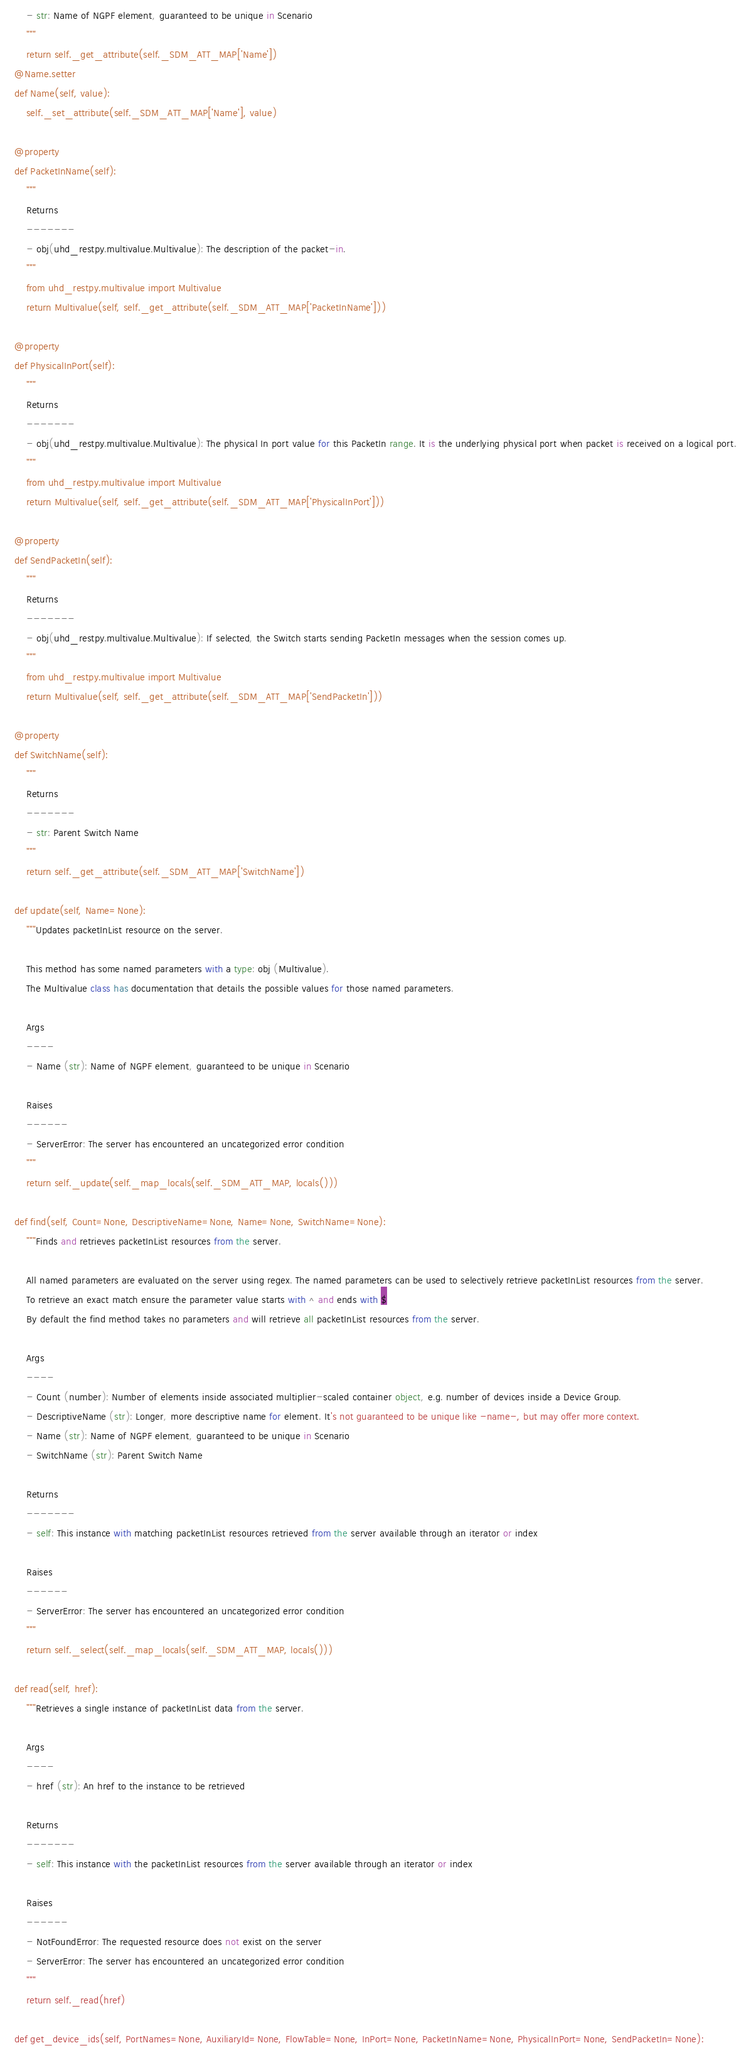<code> <loc_0><loc_0><loc_500><loc_500><_Python_>        - str: Name of NGPF element, guaranteed to be unique in Scenario
        """
        return self._get_attribute(self._SDM_ATT_MAP['Name'])
    @Name.setter
    def Name(self, value):
        self._set_attribute(self._SDM_ATT_MAP['Name'], value)

    @property
    def PacketInName(self):
        """
        Returns
        -------
        - obj(uhd_restpy.multivalue.Multivalue): The description of the packet-in.
        """
        from uhd_restpy.multivalue import Multivalue
        return Multivalue(self, self._get_attribute(self._SDM_ATT_MAP['PacketInName']))

    @property
    def PhysicalInPort(self):
        """
        Returns
        -------
        - obj(uhd_restpy.multivalue.Multivalue): The physical In port value for this PacketIn range. It is the underlying physical port when packet is received on a logical port.
        """
        from uhd_restpy.multivalue import Multivalue
        return Multivalue(self, self._get_attribute(self._SDM_ATT_MAP['PhysicalInPort']))

    @property
    def SendPacketIn(self):
        """
        Returns
        -------
        - obj(uhd_restpy.multivalue.Multivalue): If selected, the Switch starts sending PacketIn messages when the session comes up.
        """
        from uhd_restpy.multivalue import Multivalue
        return Multivalue(self, self._get_attribute(self._SDM_ATT_MAP['SendPacketIn']))

    @property
    def SwitchName(self):
        """
        Returns
        -------
        - str: Parent Switch Name
        """
        return self._get_attribute(self._SDM_ATT_MAP['SwitchName'])

    def update(self, Name=None):
        """Updates packetInList resource on the server.

        This method has some named parameters with a type: obj (Multivalue).
        The Multivalue class has documentation that details the possible values for those named parameters.

        Args
        ----
        - Name (str): Name of NGPF element, guaranteed to be unique in Scenario

        Raises
        ------
        - ServerError: The server has encountered an uncategorized error condition
        """
        return self._update(self._map_locals(self._SDM_ATT_MAP, locals()))

    def find(self, Count=None, DescriptiveName=None, Name=None, SwitchName=None):
        """Finds and retrieves packetInList resources from the server.

        All named parameters are evaluated on the server using regex. The named parameters can be used to selectively retrieve packetInList resources from the server.
        To retrieve an exact match ensure the parameter value starts with ^ and ends with $
        By default the find method takes no parameters and will retrieve all packetInList resources from the server.

        Args
        ----
        - Count (number): Number of elements inside associated multiplier-scaled container object, e.g. number of devices inside a Device Group.
        - DescriptiveName (str): Longer, more descriptive name for element. It's not guaranteed to be unique like -name-, but may offer more context.
        - Name (str): Name of NGPF element, guaranteed to be unique in Scenario
        - SwitchName (str): Parent Switch Name

        Returns
        -------
        - self: This instance with matching packetInList resources retrieved from the server available through an iterator or index

        Raises
        ------
        - ServerError: The server has encountered an uncategorized error condition
        """
        return self._select(self._map_locals(self._SDM_ATT_MAP, locals()))

    def read(self, href):
        """Retrieves a single instance of packetInList data from the server.

        Args
        ----
        - href (str): An href to the instance to be retrieved

        Returns
        -------
        - self: This instance with the packetInList resources from the server available through an iterator or index

        Raises
        ------
        - NotFoundError: The requested resource does not exist on the server
        - ServerError: The server has encountered an uncategorized error condition
        """
        return self._read(href)

    def get_device_ids(self, PortNames=None, AuxiliaryId=None, FlowTable=None, InPort=None, PacketInName=None, PhysicalInPort=None, SendPacketIn=None):</code> 